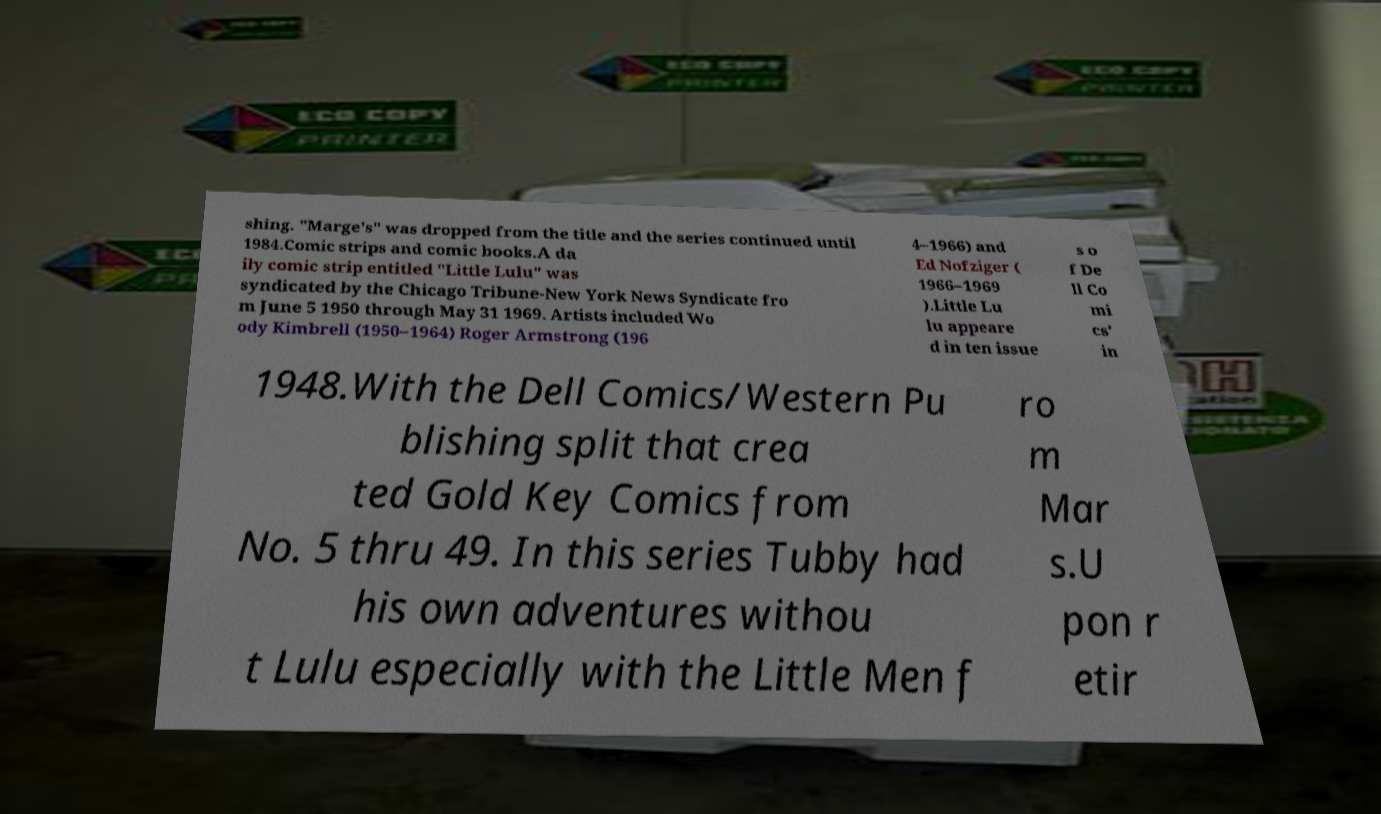For documentation purposes, I need the text within this image transcribed. Could you provide that? shing. "Marge's" was dropped from the title and the series continued until 1984.Comic strips and comic books.A da ily comic strip entitled "Little Lulu" was syndicated by the Chicago Tribune-New York News Syndicate fro m June 5 1950 through May 31 1969. Artists included Wo ody Kimbrell (1950–1964) Roger Armstrong (196 4–1966) and Ed Nofziger ( 1966–1969 ).Little Lu lu appeare d in ten issue s o f De ll Co mi cs' in 1948.With the Dell Comics/Western Pu blishing split that crea ted Gold Key Comics from No. 5 thru 49. In this series Tubby had his own adventures withou t Lulu especially with the Little Men f ro m Mar s.U pon r etir 